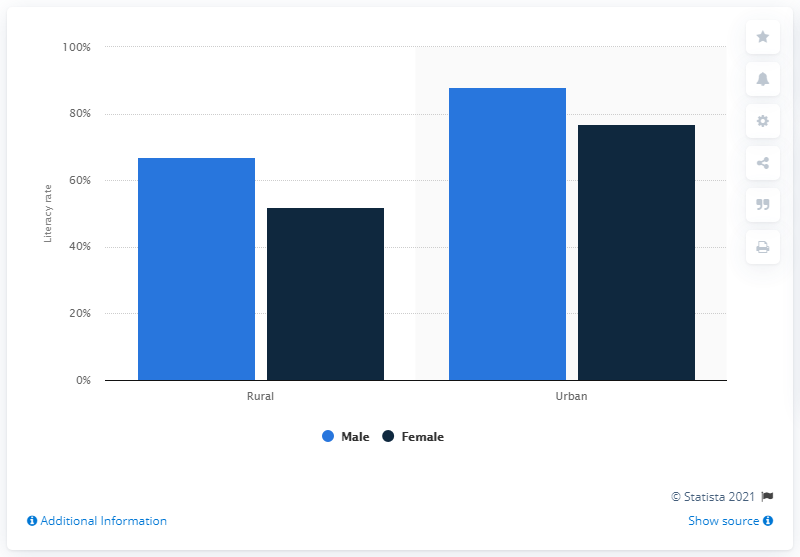List a handful of essential elements in this visual. In 2011, the literacy rate for females living in rural areas of Arunachal Pradesh was 52%. 